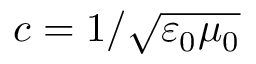Convert formula to latex. <formula><loc_0><loc_0><loc_500><loc_500>c = 1 / \sqrt { \varepsilon _ { 0 } \mu _ { 0 } }</formula> 